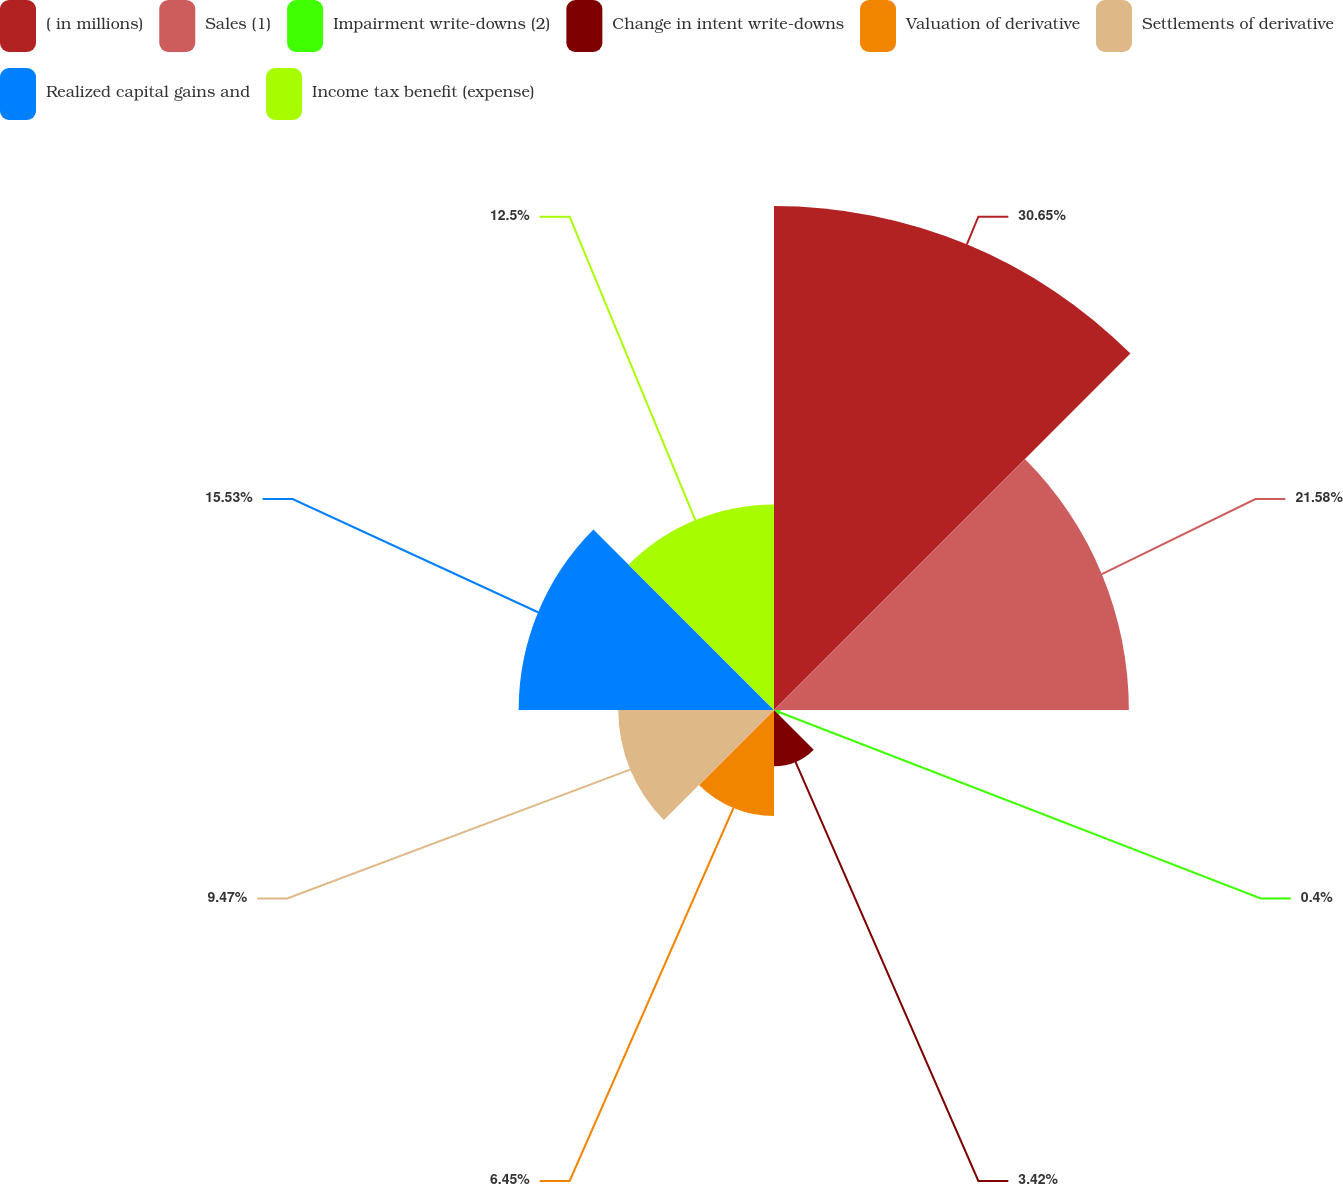Convert chart to OTSL. <chart><loc_0><loc_0><loc_500><loc_500><pie_chart><fcel>( in millions)<fcel>Sales (1)<fcel>Impairment write-downs (2)<fcel>Change in intent write-downs<fcel>Valuation of derivative<fcel>Settlements of derivative<fcel>Realized capital gains and<fcel>Income tax benefit (expense)<nl><fcel>30.65%<fcel>21.58%<fcel>0.4%<fcel>3.42%<fcel>6.45%<fcel>9.47%<fcel>15.53%<fcel>12.5%<nl></chart> 